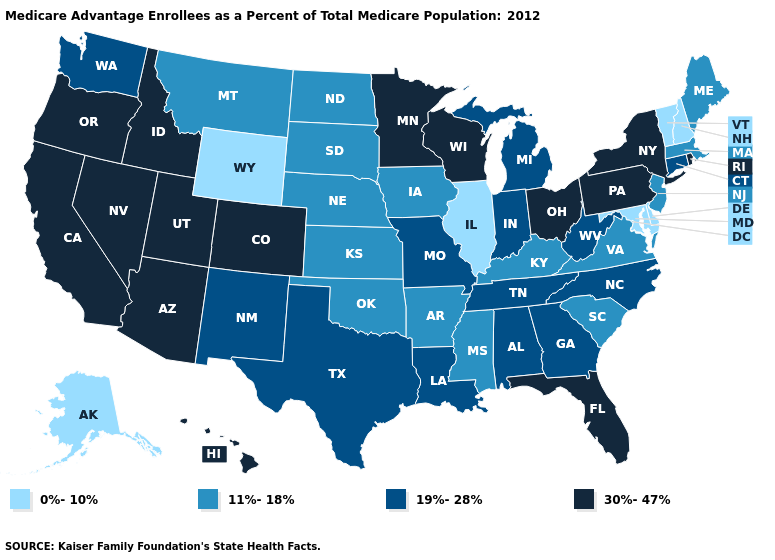Is the legend a continuous bar?
Keep it brief. No. What is the value of Illinois?
Answer briefly. 0%-10%. What is the value of Alaska?
Keep it brief. 0%-10%. What is the highest value in the USA?
Quick response, please. 30%-47%. Name the states that have a value in the range 19%-28%?
Be succinct. Alabama, Connecticut, Georgia, Indiana, Louisiana, Michigan, Missouri, North Carolina, New Mexico, Tennessee, Texas, Washington, West Virginia. How many symbols are there in the legend?
Concise answer only. 4. Does the first symbol in the legend represent the smallest category?
Give a very brief answer. Yes. Does Michigan have the lowest value in the MidWest?
Short answer required. No. What is the value of West Virginia?
Quick response, please. 19%-28%. What is the value of South Dakota?
Concise answer only. 11%-18%. Does Delaware have the lowest value in the South?
Give a very brief answer. Yes. What is the value of Alabama?
Quick response, please. 19%-28%. Does the map have missing data?
Quick response, please. No. What is the value of Colorado?
Keep it brief. 30%-47%. What is the value of Missouri?
Write a very short answer. 19%-28%. 